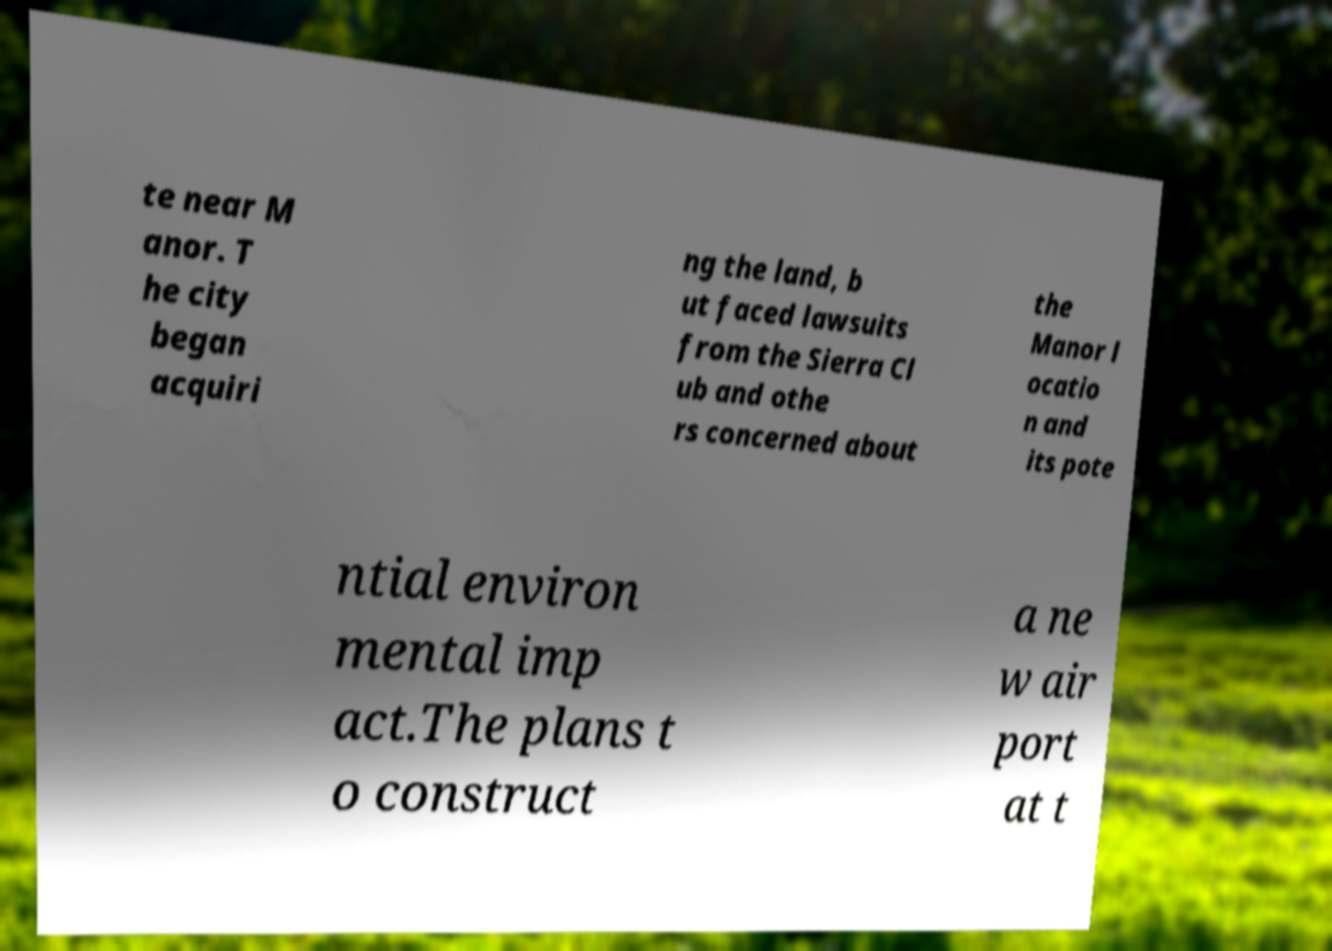Please identify and transcribe the text found in this image. te near M anor. T he city began acquiri ng the land, b ut faced lawsuits from the Sierra Cl ub and othe rs concerned about the Manor l ocatio n and its pote ntial environ mental imp act.The plans t o construct a ne w air port at t 